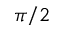<formula> <loc_0><loc_0><loc_500><loc_500>\pi / 2</formula> 